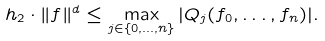<formula> <loc_0><loc_0><loc_500><loc_500>h _ { 2 } \cdot \| f \| ^ { d } \leq \max _ { j \in \{ 0 , \dots , n \} } | Q _ { j } ( f _ { 0 } , \dots , f _ { n } ) | .</formula> 